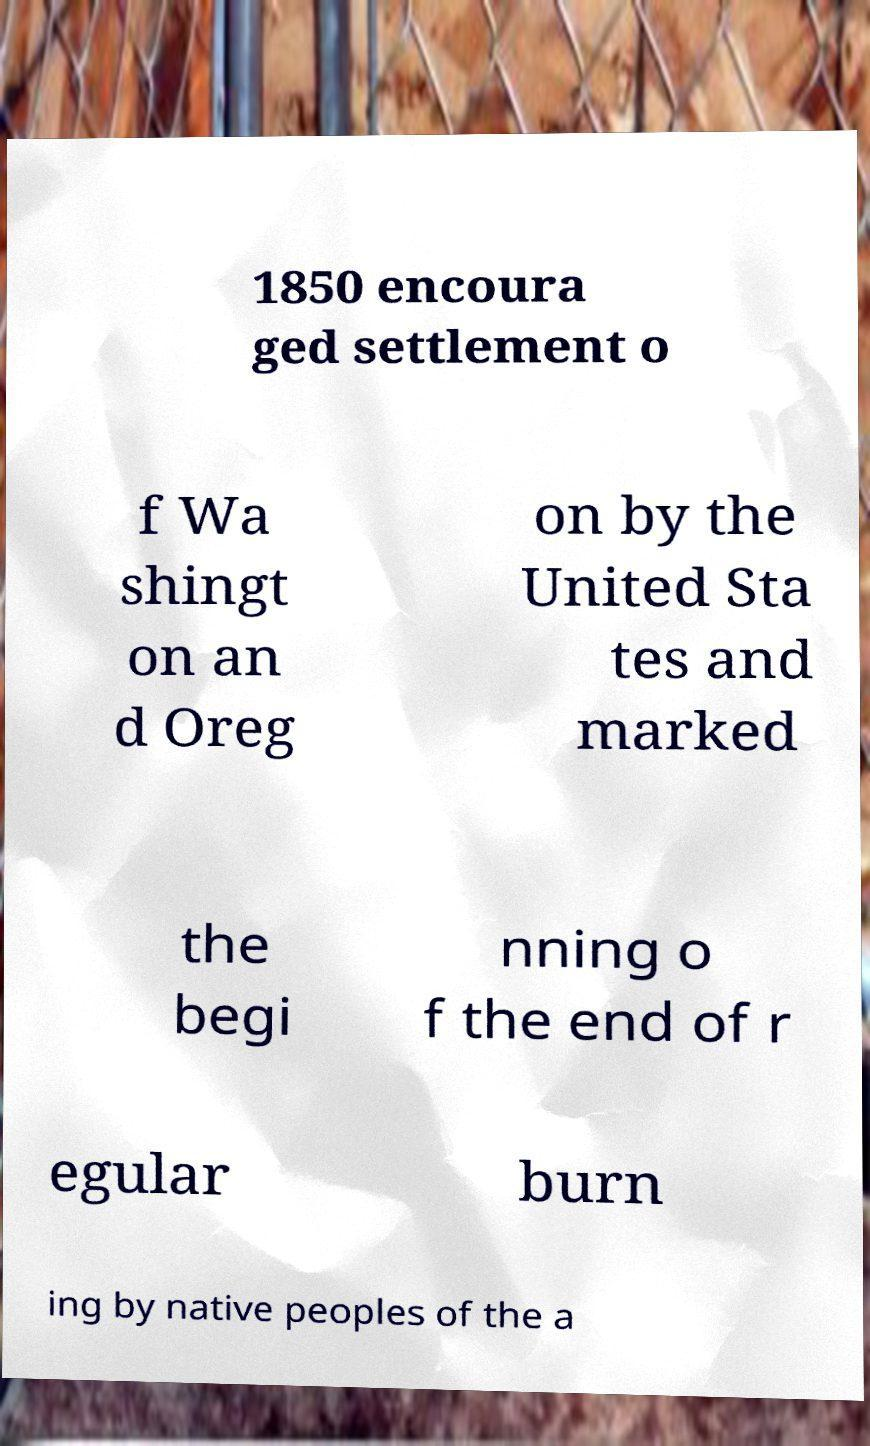Could you extract and type out the text from this image? 1850 encoura ged settlement o f Wa shingt on an d Oreg on by the United Sta tes and marked the begi nning o f the end of r egular burn ing by native peoples of the a 